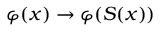<formula> <loc_0><loc_0><loc_500><loc_500>\varphi ( x ) \to \varphi ( S ( x ) )</formula> 